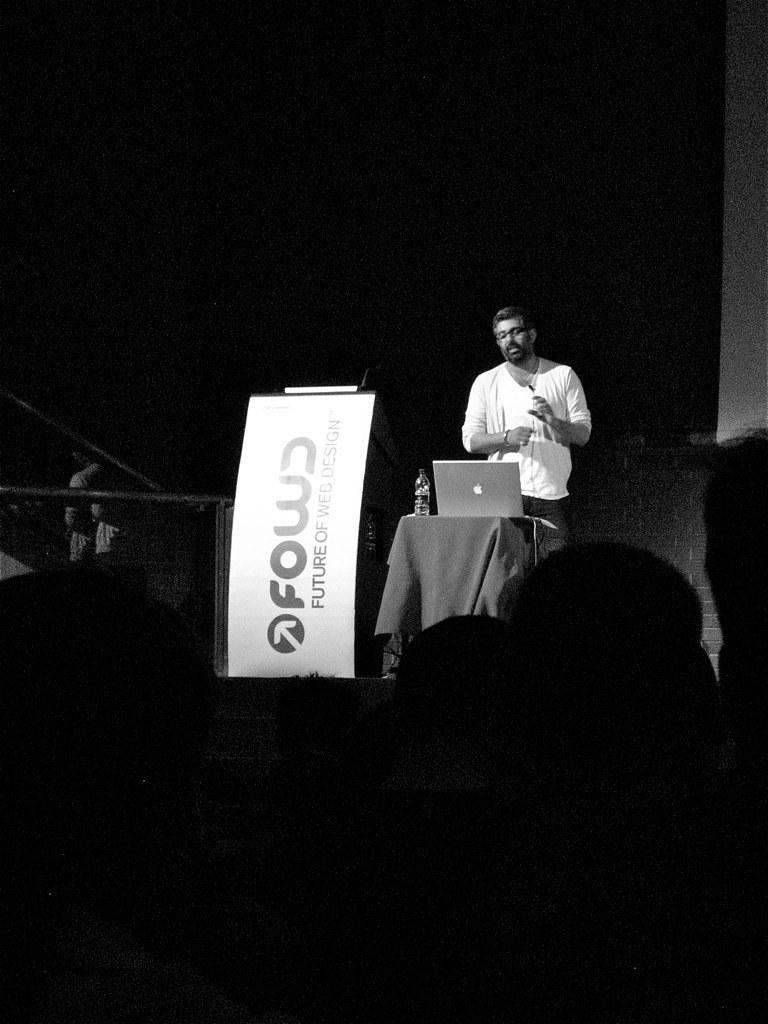Describe this image in one or two sentences. This is a black and white image. A person is standing. There is a laptop and a bottle on a table. There is a banner. 